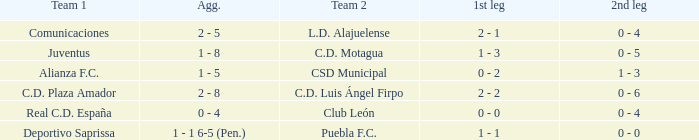What is the 2nd leg of the Comunicaciones team? 0 - 4. 